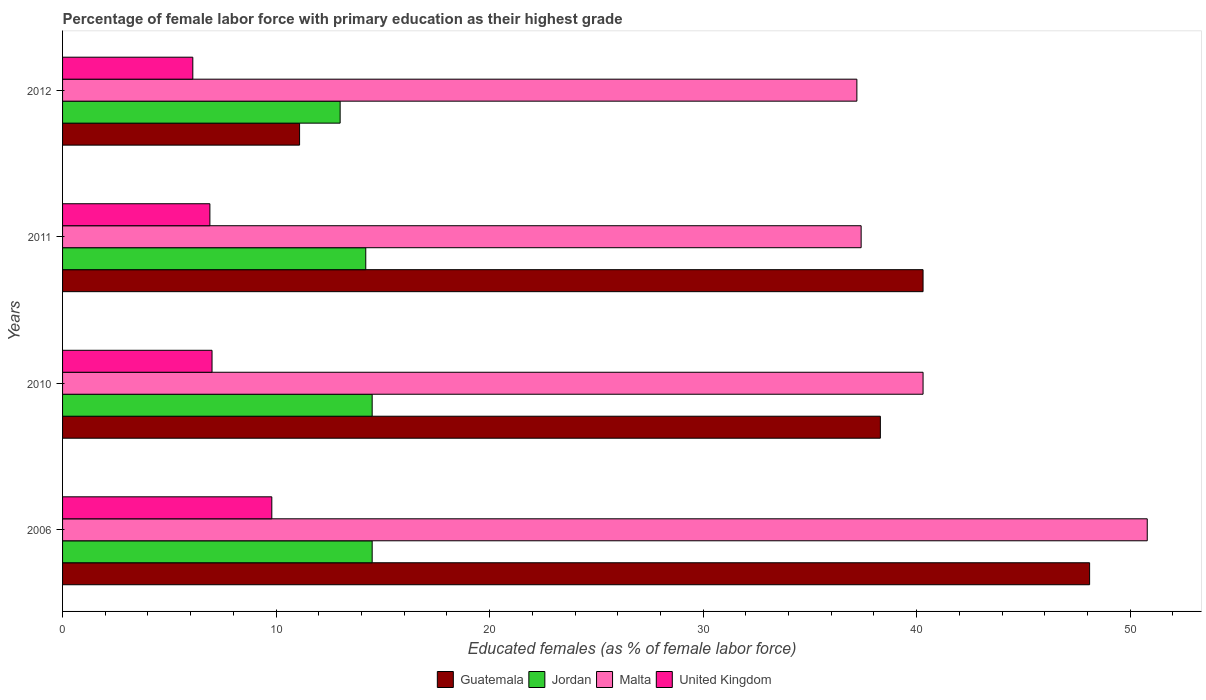How many different coloured bars are there?
Your response must be concise. 4. How many groups of bars are there?
Offer a terse response. 4. Are the number of bars per tick equal to the number of legend labels?
Your response must be concise. Yes. In how many cases, is the number of bars for a given year not equal to the number of legend labels?
Provide a short and direct response. 0. What is the percentage of female labor force with primary education in Guatemala in 2011?
Make the answer very short. 40.3. Across all years, what is the maximum percentage of female labor force with primary education in United Kingdom?
Give a very brief answer. 9.8. Across all years, what is the minimum percentage of female labor force with primary education in Guatemala?
Your response must be concise. 11.1. In which year was the percentage of female labor force with primary education in Guatemala maximum?
Your answer should be very brief. 2006. In which year was the percentage of female labor force with primary education in Jordan minimum?
Provide a short and direct response. 2012. What is the total percentage of female labor force with primary education in United Kingdom in the graph?
Your answer should be very brief. 29.8. What is the difference between the percentage of female labor force with primary education in Malta in 2006 and that in 2011?
Ensure brevity in your answer.  13.4. What is the difference between the percentage of female labor force with primary education in Malta in 2010 and the percentage of female labor force with primary education in United Kingdom in 2011?
Make the answer very short. 33.4. What is the average percentage of female labor force with primary education in Guatemala per year?
Your answer should be compact. 34.45. In the year 2011, what is the difference between the percentage of female labor force with primary education in Malta and percentage of female labor force with primary education in Guatemala?
Give a very brief answer. -2.9. In how many years, is the percentage of female labor force with primary education in Malta greater than 28 %?
Offer a very short reply. 4. What is the ratio of the percentage of female labor force with primary education in Jordan in 2006 to that in 2010?
Offer a terse response. 1. Is the percentage of female labor force with primary education in Jordan in 2006 less than that in 2011?
Your response must be concise. No. What is the difference between the highest and the lowest percentage of female labor force with primary education in Jordan?
Give a very brief answer. 1.5. Are all the bars in the graph horizontal?
Your answer should be compact. Yes. How many years are there in the graph?
Your answer should be compact. 4. What is the difference between two consecutive major ticks on the X-axis?
Your response must be concise. 10. Does the graph contain any zero values?
Your response must be concise. No. Does the graph contain grids?
Ensure brevity in your answer.  No. Where does the legend appear in the graph?
Your response must be concise. Bottom center. How many legend labels are there?
Ensure brevity in your answer.  4. What is the title of the graph?
Provide a succinct answer. Percentage of female labor force with primary education as their highest grade. What is the label or title of the X-axis?
Ensure brevity in your answer.  Educated females (as % of female labor force). What is the Educated females (as % of female labor force) in Guatemala in 2006?
Ensure brevity in your answer.  48.1. What is the Educated females (as % of female labor force) of Malta in 2006?
Keep it short and to the point. 50.8. What is the Educated females (as % of female labor force) in United Kingdom in 2006?
Offer a terse response. 9.8. What is the Educated females (as % of female labor force) in Guatemala in 2010?
Your response must be concise. 38.3. What is the Educated females (as % of female labor force) of Jordan in 2010?
Provide a succinct answer. 14.5. What is the Educated females (as % of female labor force) in Malta in 2010?
Your response must be concise. 40.3. What is the Educated females (as % of female labor force) of Guatemala in 2011?
Provide a short and direct response. 40.3. What is the Educated females (as % of female labor force) in Jordan in 2011?
Provide a short and direct response. 14.2. What is the Educated females (as % of female labor force) in Malta in 2011?
Your answer should be compact. 37.4. What is the Educated females (as % of female labor force) of United Kingdom in 2011?
Keep it short and to the point. 6.9. What is the Educated females (as % of female labor force) of Guatemala in 2012?
Offer a very short reply. 11.1. What is the Educated females (as % of female labor force) of Jordan in 2012?
Your answer should be compact. 13. What is the Educated females (as % of female labor force) in Malta in 2012?
Provide a short and direct response. 37.2. What is the Educated females (as % of female labor force) in United Kingdom in 2012?
Provide a succinct answer. 6.1. Across all years, what is the maximum Educated females (as % of female labor force) of Guatemala?
Offer a very short reply. 48.1. Across all years, what is the maximum Educated females (as % of female labor force) of Jordan?
Offer a very short reply. 14.5. Across all years, what is the maximum Educated females (as % of female labor force) in Malta?
Provide a short and direct response. 50.8. Across all years, what is the maximum Educated females (as % of female labor force) of United Kingdom?
Your answer should be very brief. 9.8. Across all years, what is the minimum Educated females (as % of female labor force) of Guatemala?
Make the answer very short. 11.1. Across all years, what is the minimum Educated females (as % of female labor force) of Malta?
Your response must be concise. 37.2. Across all years, what is the minimum Educated females (as % of female labor force) of United Kingdom?
Give a very brief answer. 6.1. What is the total Educated females (as % of female labor force) in Guatemala in the graph?
Provide a short and direct response. 137.8. What is the total Educated females (as % of female labor force) of Jordan in the graph?
Your answer should be compact. 56.2. What is the total Educated females (as % of female labor force) of Malta in the graph?
Make the answer very short. 165.7. What is the total Educated females (as % of female labor force) in United Kingdom in the graph?
Your answer should be compact. 29.8. What is the difference between the Educated females (as % of female labor force) of United Kingdom in 2006 and that in 2010?
Ensure brevity in your answer.  2.8. What is the difference between the Educated females (as % of female labor force) of Jordan in 2006 and that in 2011?
Ensure brevity in your answer.  0.3. What is the difference between the Educated females (as % of female labor force) of Malta in 2006 and that in 2011?
Make the answer very short. 13.4. What is the difference between the Educated females (as % of female labor force) in Malta in 2006 and that in 2012?
Your answer should be compact. 13.6. What is the difference between the Educated females (as % of female labor force) in United Kingdom in 2006 and that in 2012?
Give a very brief answer. 3.7. What is the difference between the Educated females (as % of female labor force) in Jordan in 2010 and that in 2011?
Keep it short and to the point. 0.3. What is the difference between the Educated females (as % of female labor force) of United Kingdom in 2010 and that in 2011?
Your answer should be compact. 0.1. What is the difference between the Educated females (as % of female labor force) of Guatemala in 2010 and that in 2012?
Offer a terse response. 27.2. What is the difference between the Educated females (as % of female labor force) of Malta in 2010 and that in 2012?
Your response must be concise. 3.1. What is the difference between the Educated females (as % of female labor force) of Guatemala in 2011 and that in 2012?
Provide a succinct answer. 29.2. What is the difference between the Educated females (as % of female labor force) in Jordan in 2011 and that in 2012?
Your answer should be very brief. 1.2. What is the difference between the Educated females (as % of female labor force) in Guatemala in 2006 and the Educated females (as % of female labor force) in Jordan in 2010?
Keep it short and to the point. 33.6. What is the difference between the Educated females (as % of female labor force) of Guatemala in 2006 and the Educated females (as % of female labor force) of Malta in 2010?
Ensure brevity in your answer.  7.8. What is the difference between the Educated females (as % of female labor force) of Guatemala in 2006 and the Educated females (as % of female labor force) of United Kingdom in 2010?
Provide a short and direct response. 41.1. What is the difference between the Educated females (as % of female labor force) of Jordan in 2006 and the Educated females (as % of female labor force) of Malta in 2010?
Your answer should be very brief. -25.8. What is the difference between the Educated females (as % of female labor force) in Malta in 2006 and the Educated females (as % of female labor force) in United Kingdom in 2010?
Make the answer very short. 43.8. What is the difference between the Educated females (as % of female labor force) of Guatemala in 2006 and the Educated females (as % of female labor force) of Jordan in 2011?
Your response must be concise. 33.9. What is the difference between the Educated females (as % of female labor force) of Guatemala in 2006 and the Educated females (as % of female labor force) of United Kingdom in 2011?
Offer a very short reply. 41.2. What is the difference between the Educated females (as % of female labor force) in Jordan in 2006 and the Educated females (as % of female labor force) in Malta in 2011?
Your answer should be compact. -22.9. What is the difference between the Educated females (as % of female labor force) of Malta in 2006 and the Educated females (as % of female labor force) of United Kingdom in 2011?
Your answer should be compact. 43.9. What is the difference between the Educated females (as % of female labor force) in Guatemala in 2006 and the Educated females (as % of female labor force) in Jordan in 2012?
Offer a very short reply. 35.1. What is the difference between the Educated females (as % of female labor force) of Guatemala in 2006 and the Educated females (as % of female labor force) of Malta in 2012?
Your answer should be very brief. 10.9. What is the difference between the Educated females (as % of female labor force) of Jordan in 2006 and the Educated females (as % of female labor force) of Malta in 2012?
Your response must be concise. -22.7. What is the difference between the Educated females (as % of female labor force) in Malta in 2006 and the Educated females (as % of female labor force) in United Kingdom in 2012?
Offer a terse response. 44.7. What is the difference between the Educated females (as % of female labor force) of Guatemala in 2010 and the Educated females (as % of female labor force) of Jordan in 2011?
Your answer should be compact. 24.1. What is the difference between the Educated females (as % of female labor force) in Guatemala in 2010 and the Educated females (as % of female labor force) in Malta in 2011?
Your answer should be very brief. 0.9. What is the difference between the Educated females (as % of female labor force) of Guatemala in 2010 and the Educated females (as % of female labor force) of United Kingdom in 2011?
Your response must be concise. 31.4. What is the difference between the Educated females (as % of female labor force) in Jordan in 2010 and the Educated females (as % of female labor force) in Malta in 2011?
Your answer should be compact. -22.9. What is the difference between the Educated females (as % of female labor force) in Jordan in 2010 and the Educated females (as % of female labor force) in United Kingdom in 2011?
Offer a very short reply. 7.6. What is the difference between the Educated females (as % of female labor force) in Malta in 2010 and the Educated females (as % of female labor force) in United Kingdom in 2011?
Offer a very short reply. 33.4. What is the difference between the Educated females (as % of female labor force) of Guatemala in 2010 and the Educated females (as % of female labor force) of Jordan in 2012?
Provide a short and direct response. 25.3. What is the difference between the Educated females (as % of female labor force) of Guatemala in 2010 and the Educated females (as % of female labor force) of Malta in 2012?
Give a very brief answer. 1.1. What is the difference between the Educated females (as % of female labor force) of Guatemala in 2010 and the Educated females (as % of female labor force) of United Kingdom in 2012?
Make the answer very short. 32.2. What is the difference between the Educated females (as % of female labor force) in Jordan in 2010 and the Educated females (as % of female labor force) in Malta in 2012?
Keep it short and to the point. -22.7. What is the difference between the Educated females (as % of female labor force) in Jordan in 2010 and the Educated females (as % of female labor force) in United Kingdom in 2012?
Offer a very short reply. 8.4. What is the difference between the Educated females (as % of female labor force) in Malta in 2010 and the Educated females (as % of female labor force) in United Kingdom in 2012?
Your answer should be very brief. 34.2. What is the difference between the Educated females (as % of female labor force) of Guatemala in 2011 and the Educated females (as % of female labor force) of Jordan in 2012?
Provide a short and direct response. 27.3. What is the difference between the Educated females (as % of female labor force) in Guatemala in 2011 and the Educated females (as % of female labor force) in United Kingdom in 2012?
Ensure brevity in your answer.  34.2. What is the difference between the Educated females (as % of female labor force) in Jordan in 2011 and the Educated females (as % of female labor force) in Malta in 2012?
Your answer should be very brief. -23. What is the difference between the Educated females (as % of female labor force) of Malta in 2011 and the Educated females (as % of female labor force) of United Kingdom in 2012?
Provide a short and direct response. 31.3. What is the average Educated females (as % of female labor force) in Guatemala per year?
Give a very brief answer. 34.45. What is the average Educated females (as % of female labor force) of Jordan per year?
Provide a succinct answer. 14.05. What is the average Educated females (as % of female labor force) of Malta per year?
Keep it short and to the point. 41.42. What is the average Educated females (as % of female labor force) in United Kingdom per year?
Keep it short and to the point. 7.45. In the year 2006, what is the difference between the Educated females (as % of female labor force) in Guatemala and Educated females (as % of female labor force) in Jordan?
Give a very brief answer. 33.6. In the year 2006, what is the difference between the Educated females (as % of female labor force) in Guatemala and Educated females (as % of female labor force) in United Kingdom?
Give a very brief answer. 38.3. In the year 2006, what is the difference between the Educated females (as % of female labor force) in Jordan and Educated females (as % of female labor force) in Malta?
Provide a short and direct response. -36.3. In the year 2006, what is the difference between the Educated females (as % of female labor force) in Jordan and Educated females (as % of female labor force) in United Kingdom?
Give a very brief answer. 4.7. In the year 2006, what is the difference between the Educated females (as % of female labor force) in Malta and Educated females (as % of female labor force) in United Kingdom?
Provide a succinct answer. 41. In the year 2010, what is the difference between the Educated females (as % of female labor force) of Guatemala and Educated females (as % of female labor force) of Jordan?
Ensure brevity in your answer.  23.8. In the year 2010, what is the difference between the Educated females (as % of female labor force) in Guatemala and Educated females (as % of female labor force) in United Kingdom?
Give a very brief answer. 31.3. In the year 2010, what is the difference between the Educated females (as % of female labor force) of Jordan and Educated females (as % of female labor force) of Malta?
Your response must be concise. -25.8. In the year 2010, what is the difference between the Educated females (as % of female labor force) in Jordan and Educated females (as % of female labor force) in United Kingdom?
Provide a short and direct response. 7.5. In the year 2010, what is the difference between the Educated females (as % of female labor force) in Malta and Educated females (as % of female labor force) in United Kingdom?
Your response must be concise. 33.3. In the year 2011, what is the difference between the Educated females (as % of female labor force) in Guatemala and Educated females (as % of female labor force) in Jordan?
Your answer should be compact. 26.1. In the year 2011, what is the difference between the Educated females (as % of female labor force) of Guatemala and Educated females (as % of female labor force) of Malta?
Provide a succinct answer. 2.9. In the year 2011, what is the difference between the Educated females (as % of female labor force) of Guatemala and Educated females (as % of female labor force) of United Kingdom?
Offer a terse response. 33.4. In the year 2011, what is the difference between the Educated females (as % of female labor force) in Jordan and Educated females (as % of female labor force) in Malta?
Your response must be concise. -23.2. In the year 2011, what is the difference between the Educated females (as % of female labor force) of Malta and Educated females (as % of female labor force) of United Kingdom?
Offer a very short reply. 30.5. In the year 2012, what is the difference between the Educated females (as % of female labor force) of Guatemala and Educated females (as % of female labor force) of Jordan?
Ensure brevity in your answer.  -1.9. In the year 2012, what is the difference between the Educated females (as % of female labor force) in Guatemala and Educated females (as % of female labor force) in Malta?
Your response must be concise. -26.1. In the year 2012, what is the difference between the Educated females (as % of female labor force) in Guatemala and Educated females (as % of female labor force) in United Kingdom?
Provide a short and direct response. 5. In the year 2012, what is the difference between the Educated females (as % of female labor force) of Jordan and Educated females (as % of female labor force) of Malta?
Ensure brevity in your answer.  -24.2. In the year 2012, what is the difference between the Educated females (as % of female labor force) in Malta and Educated females (as % of female labor force) in United Kingdom?
Give a very brief answer. 31.1. What is the ratio of the Educated females (as % of female labor force) of Guatemala in 2006 to that in 2010?
Your response must be concise. 1.26. What is the ratio of the Educated females (as % of female labor force) in Malta in 2006 to that in 2010?
Give a very brief answer. 1.26. What is the ratio of the Educated females (as % of female labor force) of United Kingdom in 2006 to that in 2010?
Your response must be concise. 1.4. What is the ratio of the Educated females (as % of female labor force) of Guatemala in 2006 to that in 2011?
Ensure brevity in your answer.  1.19. What is the ratio of the Educated females (as % of female labor force) of Jordan in 2006 to that in 2011?
Keep it short and to the point. 1.02. What is the ratio of the Educated females (as % of female labor force) in Malta in 2006 to that in 2011?
Offer a very short reply. 1.36. What is the ratio of the Educated females (as % of female labor force) of United Kingdom in 2006 to that in 2011?
Offer a very short reply. 1.42. What is the ratio of the Educated females (as % of female labor force) of Guatemala in 2006 to that in 2012?
Ensure brevity in your answer.  4.33. What is the ratio of the Educated females (as % of female labor force) in Jordan in 2006 to that in 2012?
Your answer should be compact. 1.12. What is the ratio of the Educated females (as % of female labor force) in Malta in 2006 to that in 2012?
Keep it short and to the point. 1.37. What is the ratio of the Educated females (as % of female labor force) of United Kingdom in 2006 to that in 2012?
Offer a terse response. 1.61. What is the ratio of the Educated females (as % of female labor force) in Guatemala in 2010 to that in 2011?
Your answer should be compact. 0.95. What is the ratio of the Educated females (as % of female labor force) of Jordan in 2010 to that in 2011?
Your response must be concise. 1.02. What is the ratio of the Educated females (as % of female labor force) of Malta in 2010 to that in 2011?
Your answer should be very brief. 1.08. What is the ratio of the Educated females (as % of female labor force) of United Kingdom in 2010 to that in 2011?
Ensure brevity in your answer.  1.01. What is the ratio of the Educated females (as % of female labor force) in Guatemala in 2010 to that in 2012?
Provide a succinct answer. 3.45. What is the ratio of the Educated females (as % of female labor force) of Jordan in 2010 to that in 2012?
Offer a terse response. 1.12. What is the ratio of the Educated females (as % of female labor force) of Malta in 2010 to that in 2012?
Your answer should be very brief. 1.08. What is the ratio of the Educated females (as % of female labor force) of United Kingdom in 2010 to that in 2012?
Your response must be concise. 1.15. What is the ratio of the Educated females (as % of female labor force) of Guatemala in 2011 to that in 2012?
Offer a very short reply. 3.63. What is the ratio of the Educated females (as % of female labor force) in Jordan in 2011 to that in 2012?
Keep it short and to the point. 1.09. What is the ratio of the Educated females (as % of female labor force) of Malta in 2011 to that in 2012?
Make the answer very short. 1.01. What is the ratio of the Educated females (as % of female labor force) in United Kingdom in 2011 to that in 2012?
Offer a terse response. 1.13. What is the difference between the highest and the second highest Educated females (as % of female labor force) of Jordan?
Your answer should be very brief. 0. 